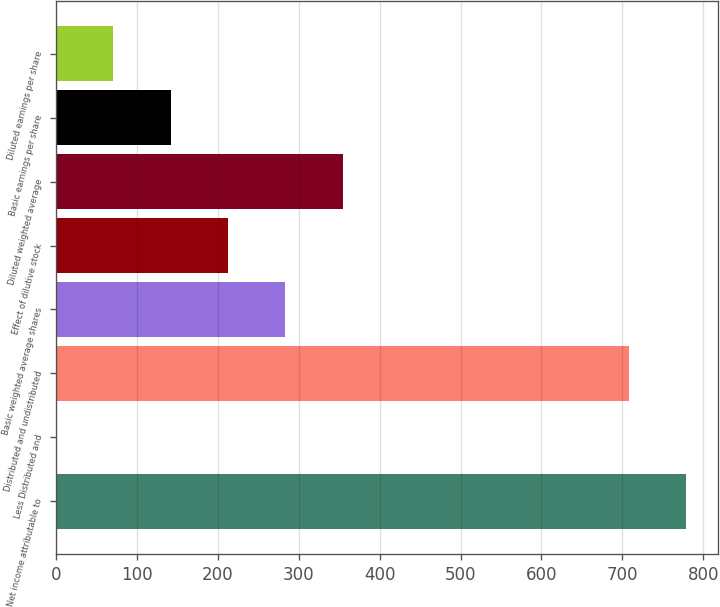<chart> <loc_0><loc_0><loc_500><loc_500><bar_chart><fcel>Net income attributable to<fcel>Less Distributed and<fcel>Distributed and undistributed<fcel>Basic weighted average shares<fcel>Effect of dilutive stock<fcel>Diluted weighted average<fcel>Basic earnings per share<fcel>Diluted earnings per share<nl><fcel>778.91<fcel>0.1<fcel>708.1<fcel>283.34<fcel>212.53<fcel>354.15<fcel>141.72<fcel>70.91<nl></chart> 